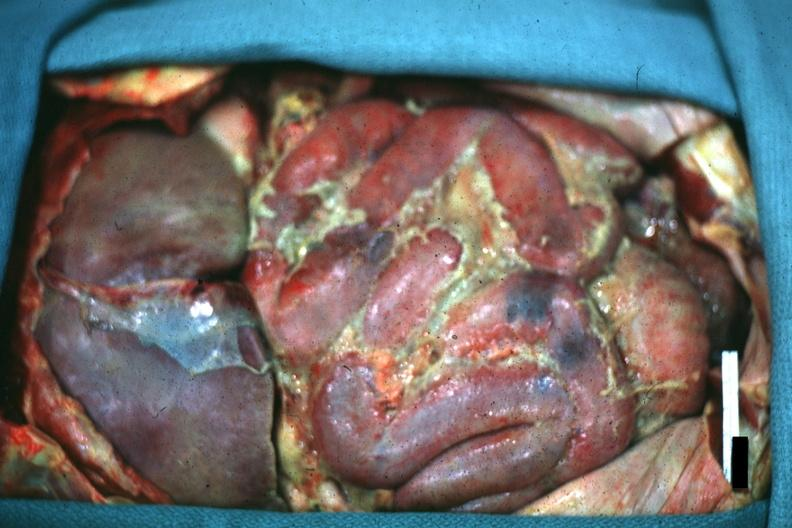does abdomen show opened peritoneum with fibrinopurulent peritonitis?
Answer the question using a single word or phrase. No 